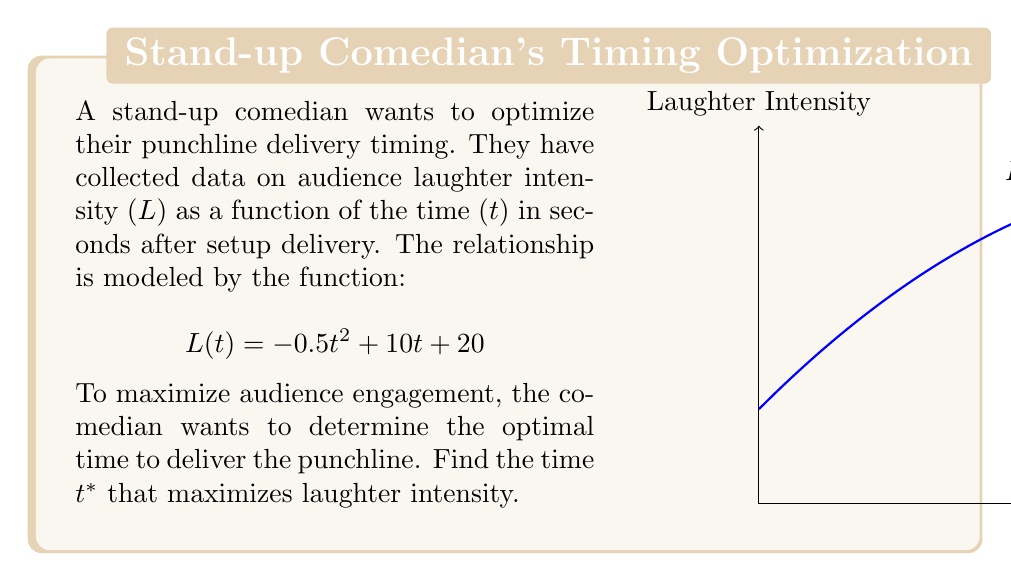Solve this math problem. To find the optimal time for punchline delivery, we need to maximize the laughter intensity function L(t). This can be done by finding the critical point where the derivative of L(t) equals zero.

Step 1: Find the derivative of L(t)
$$L'(t) = \frac{d}{dt}(-0.5t^2 + 10t + 20) = -t + 10$$

Step 2: Set the derivative equal to zero and solve for t
$$L'(t) = 0$$
$$-t + 10 = 0$$
$$t = 10$$

Step 3: Verify this is a maximum by checking the second derivative
$$L''(t) = \frac{d}{dt}(-t + 10) = -1$$

Since L''(t) is negative, we confirm that t = 10 gives a maximum.

Step 4: Calculate the maximum laughter intensity
$$L(10) = -0.5(10)^2 + 10(10) + 20 = -50 + 100 + 20 = 70$$

Therefore, the optimal time to deliver the punchline is 10 seconds after the setup, resulting in a maximum laughter intensity of 70.
Answer: 10 seconds 